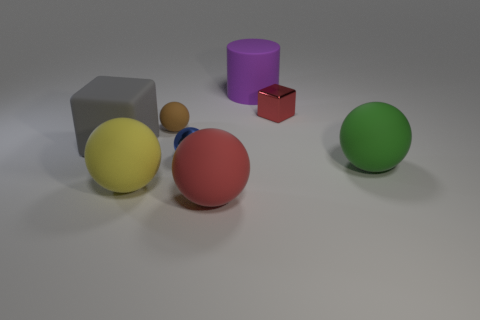Subtract all brown spheres. How many spheres are left? 4 Subtract all rubber balls. How many balls are left? 1 Subtract 1 balls. How many balls are left? 4 Add 2 green metallic cubes. How many objects exist? 10 Subtract all purple spheres. Subtract all green blocks. How many spheres are left? 5 Subtract all cylinders. How many objects are left? 7 Subtract all tiny blue balls. Subtract all metallic spheres. How many objects are left? 6 Add 1 red matte objects. How many red matte objects are left? 2 Add 3 tiny yellow rubber cylinders. How many tiny yellow rubber cylinders exist? 3 Subtract 0 blue cylinders. How many objects are left? 8 